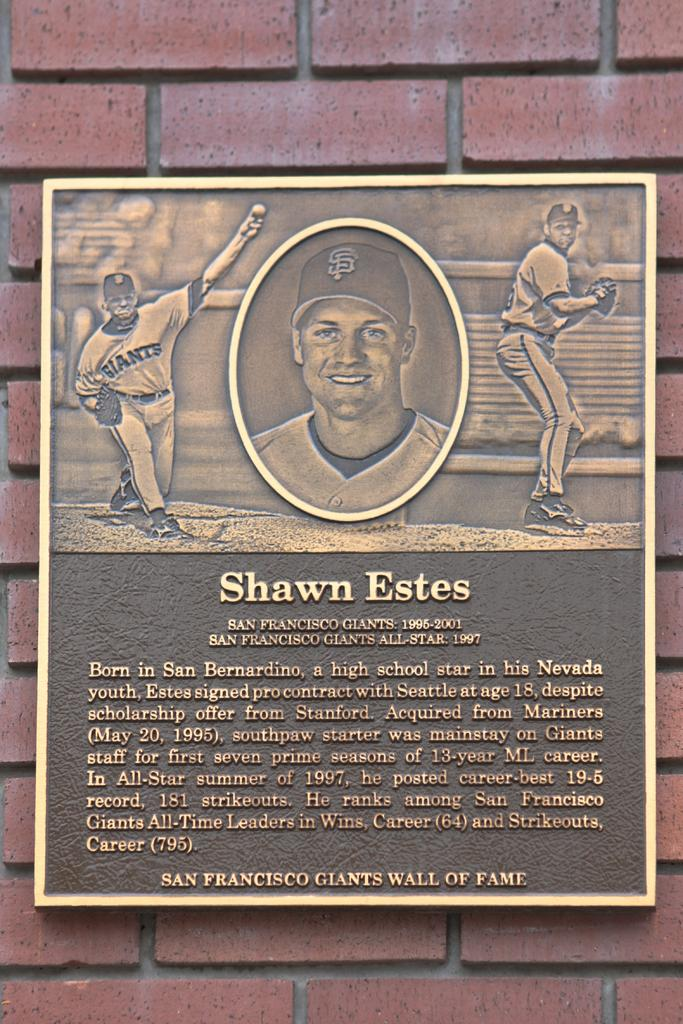What is the main object in the image? There is a board in the image. How is the board positioned in the image? The board is attached to a brown color brick wall. What type of underwear is hanging on the board in the image? There is no underwear present in the image; it only features a board attached to a brown color brick wall. 